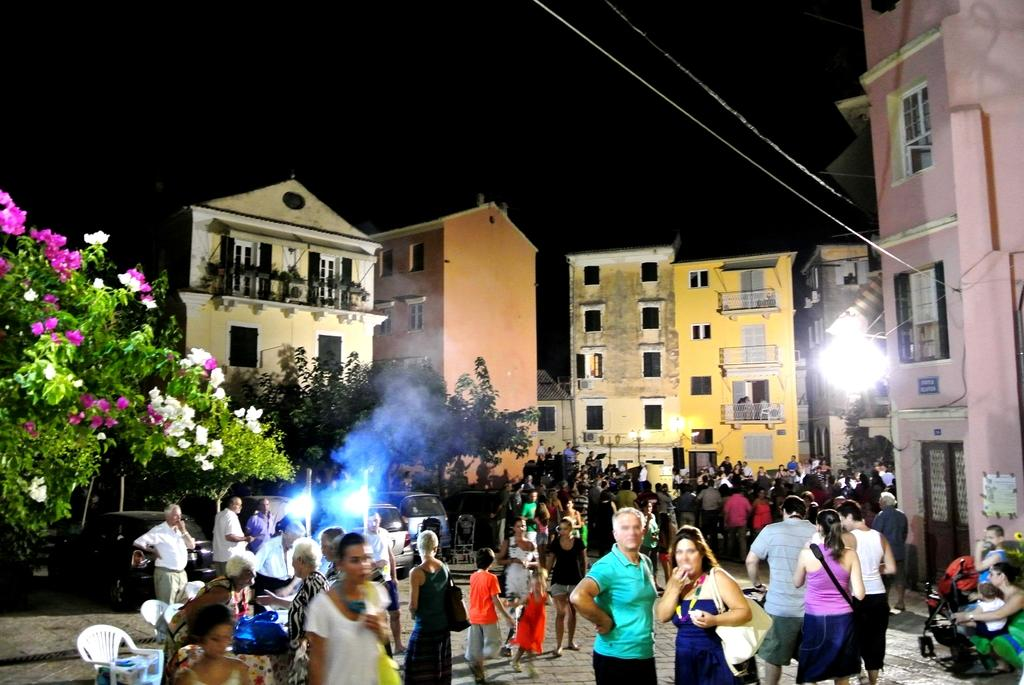What are the people in the image doing? There are people sitting and standing in the image. What can be seen illuminating the scene in the image? There are lights visible in the image. What type of furniture is present in the image? Chairs are present in the image. What is on the table in the image? There are objects on the table. What is visible in the background of the image? The background of the image includes people, trees, flowers, and windows. Can you see any fairies dancing among the flowers in the background of the image? There are no fairies present in the image; only people, trees, flowers, and windows are visible in the background. 